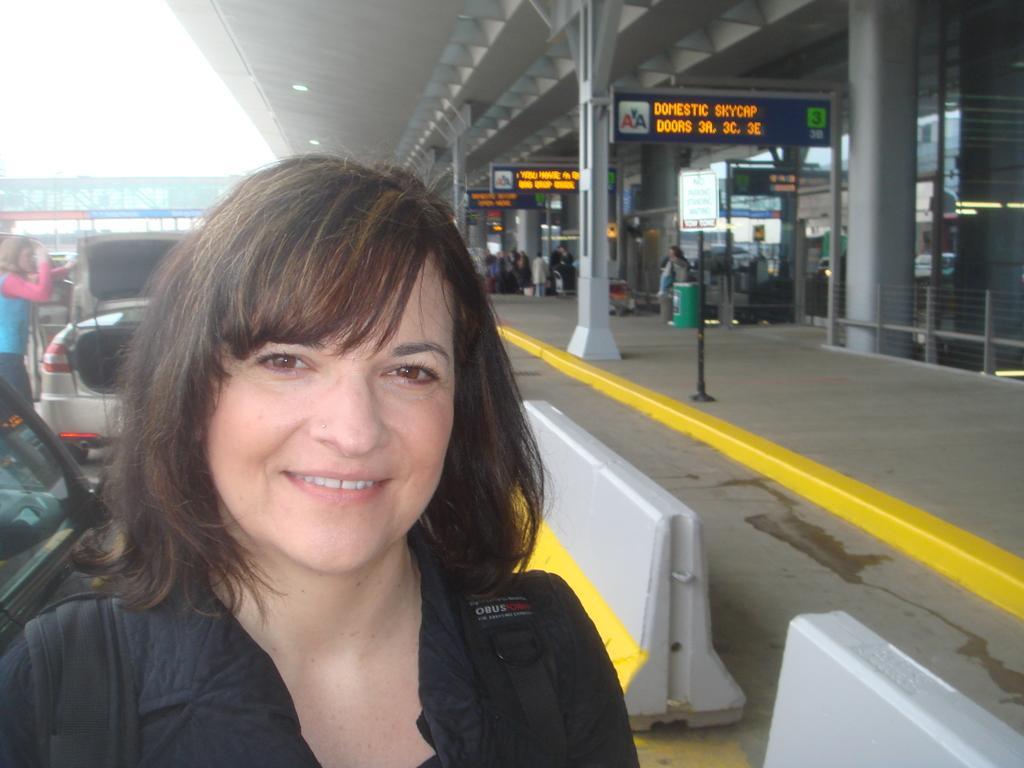Could you give a brief overview of what you see in this image? In this image we can see people and there are vehicles. There is a platform and we can see boards. There are railings and we can see a bin. In the background there is sky. 